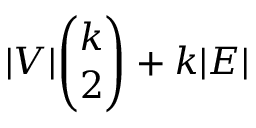<formula> <loc_0><loc_0><loc_500><loc_500>| V | \binom { k } { 2 } + k | E |</formula> 